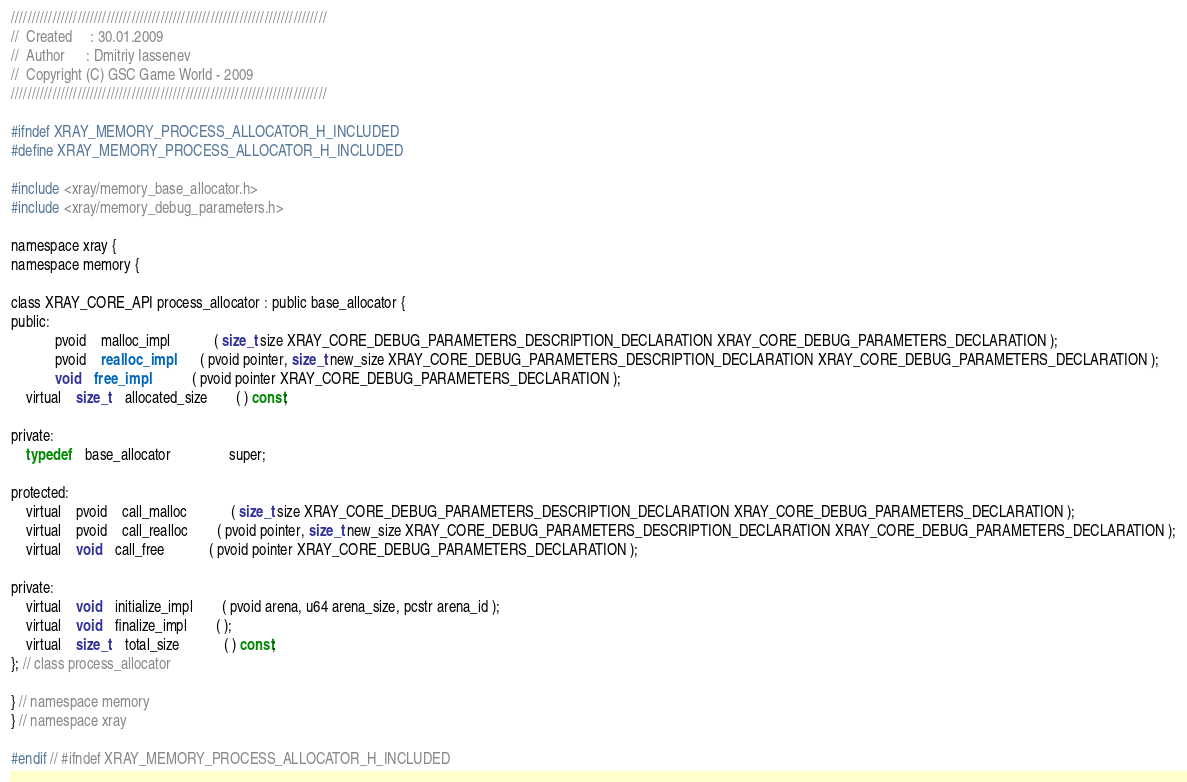<code> <loc_0><loc_0><loc_500><loc_500><_C_>////////////////////////////////////////////////////////////////////////////
//	Created		: 30.01.2009
//	Author		: Dmitriy Iassenev
//	Copyright (C) GSC Game World - 2009
////////////////////////////////////////////////////////////////////////////

#ifndef XRAY_MEMORY_PROCESS_ALLOCATOR_H_INCLUDED
#define XRAY_MEMORY_PROCESS_ALLOCATOR_H_INCLUDED

#include <xray/memory_base_allocator.h>
#include <xray/memory_debug_parameters.h>

namespace xray {
namespace memory {

class XRAY_CORE_API process_allocator : public base_allocator {
public:
			pvoid	malloc_impl			( size_t size XRAY_CORE_DEBUG_PARAMETERS_DESCRIPTION_DECLARATION XRAY_CORE_DEBUG_PARAMETERS_DECLARATION );
			pvoid	realloc_impl		( pvoid pointer, size_t new_size XRAY_CORE_DEBUG_PARAMETERS_DESCRIPTION_DECLARATION XRAY_CORE_DEBUG_PARAMETERS_DECLARATION );
			void	free_impl			( pvoid pointer XRAY_CORE_DEBUG_PARAMETERS_DECLARATION );
	virtual	size_t	allocated_size		( ) const;

private:
	typedef	base_allocator				super;

protected:
	virtual	pvoid	call_malloc			( size_t size XRAY_CORE_DEBUG_PARAMETERS_DESCRIPTION_DECLARATION XRAY_CORE_DEBUG_PARAMETERS_DECLARATION );
	virtual	pvoid	call_realloc		( pvoid pointer, size_t new_size XRAY_CORE_DEBUG_PARAMETERS_DESCRIPTION_DECLARATION XRAY_CORE_DEBUG_PARAMETERS_DECLARATION );
	virtual	void	call_free			( pvoid pointer XRAY_CORE_DEBUG_PARAMETERS_DECLARATION );

private:
	virtual	void	initialize_impl		( pvoid arena, u64 arena_size, pcstr arena_id );
	virtual	void	finalize_impl		( );
	virtual	size_t	total_size			( ) const;
}; // class process_allocator

} // namespace memory
} // namespace xray

#endif // #ifndef XRAY_MEMORY_PROCESS_ALLOCATOR_H_INCLUDED</code> 